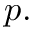Convert formula to latex. <formula><loc_0><loc_0><loc_500><loc_500>p .</formula> 